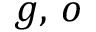<formula> <loc_0><loc_0><loc_500><loc_500>g , \, o</formula> 